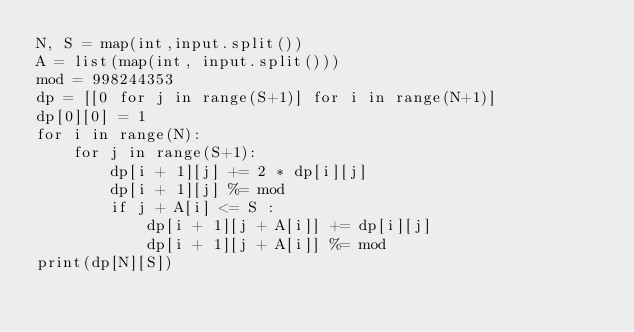Convert code to text. <code><loc_0><loc_0><loc_500><loc_500><_Python_>N, S = map(int,input.split())
A = list(map(int, input.split()))
mod = 998244353
dp = [[0 for j in range(S+1)] for i in range(N+1)]
dp[0][0] = 1
for i in range(N):
	for j in range(S+1):
		dp[i + 1][j] += 2 * dp[i][j]
		dp[i + 1][j] %= mod 
		if j + A[i] <= S : 
			dp[i + 1][j + A[i]] += dp[i][j]
			dp[i + 1][j + A[i]] %= mod
print(dp[N][S])
</code> 